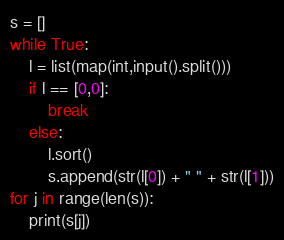Convert code to text. <code><loc_0><loc_0><loc_500><loc_500><_Python_>s = []
while True:
    l = list(map(int,input().split()))
    if l == [0,0]:
        break
    else:
        l.sort()
        s.append(str(l[0]) + " " + str(l[1]))
for j in range(len(s)):
    print(s[j])</code> 